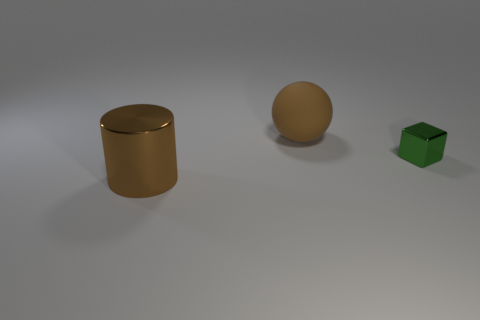Add 2 big gray cubes. How many objects exist? 5 Subtract all cubes. How many objects are left? 2 Add 2 matte things. How many matte things are left? 3 Add 1 tiny red metallic cylinders. How many tiny red metallic cylinders exist? 1 Subtract 0 red cylinders. How many objects are left? 3 Subtract all brown metallic objects. Subtract all large brown shiny things. How many objects are left? 1 